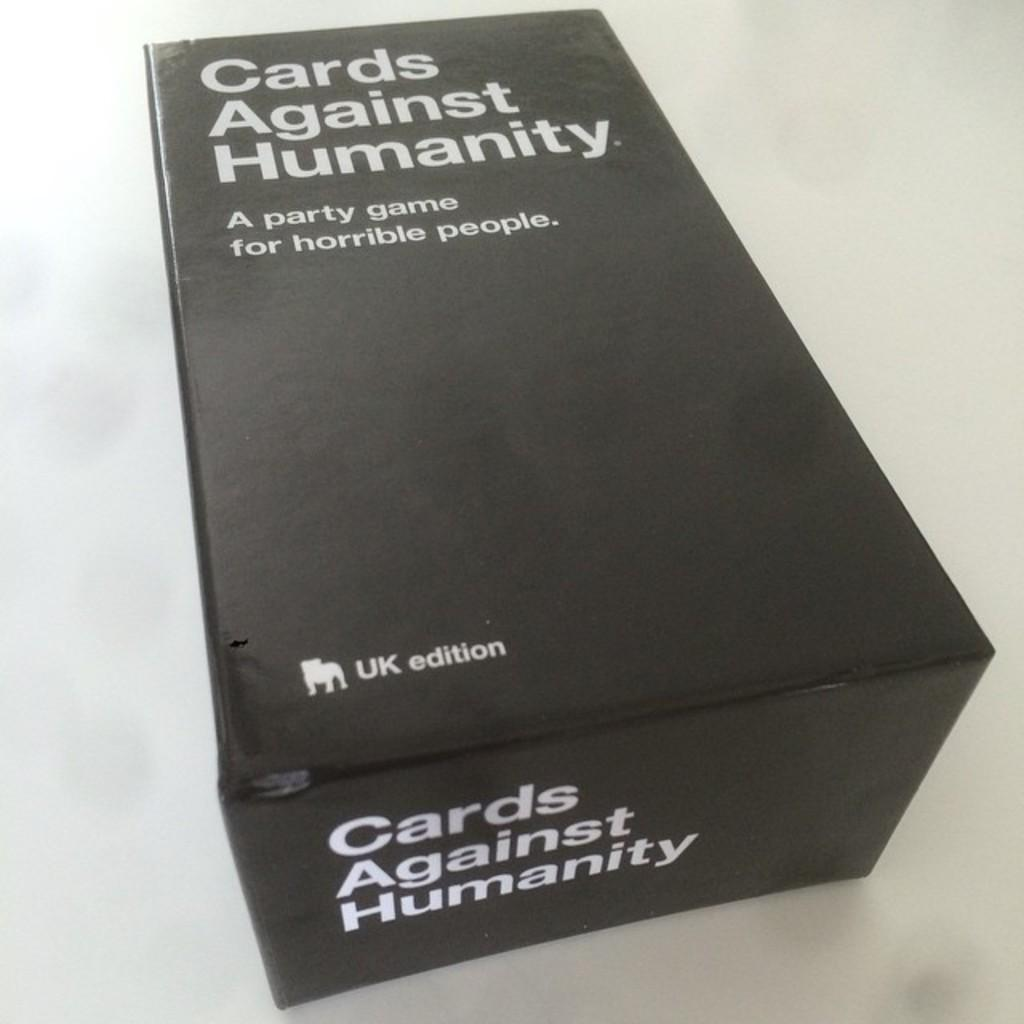<image>
Relay a brief, clear account of the picture shown. A card game is in black packaging on the table. 